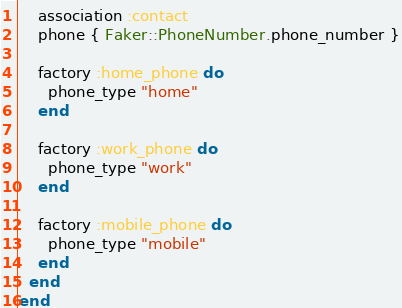<code> <loc_0><loc_0><loc_500><loc_500><_Ruby_>    association :contact
    phone { Faker::PhoneNumber.phone_number }

    factory :home_phone do
      phone_type "home"
    end

    factory :work_phone do
      phone_type "work"
    end

    factory :mobile_phone do
      phone_type "mobile"
    end
  end
end
</code> 